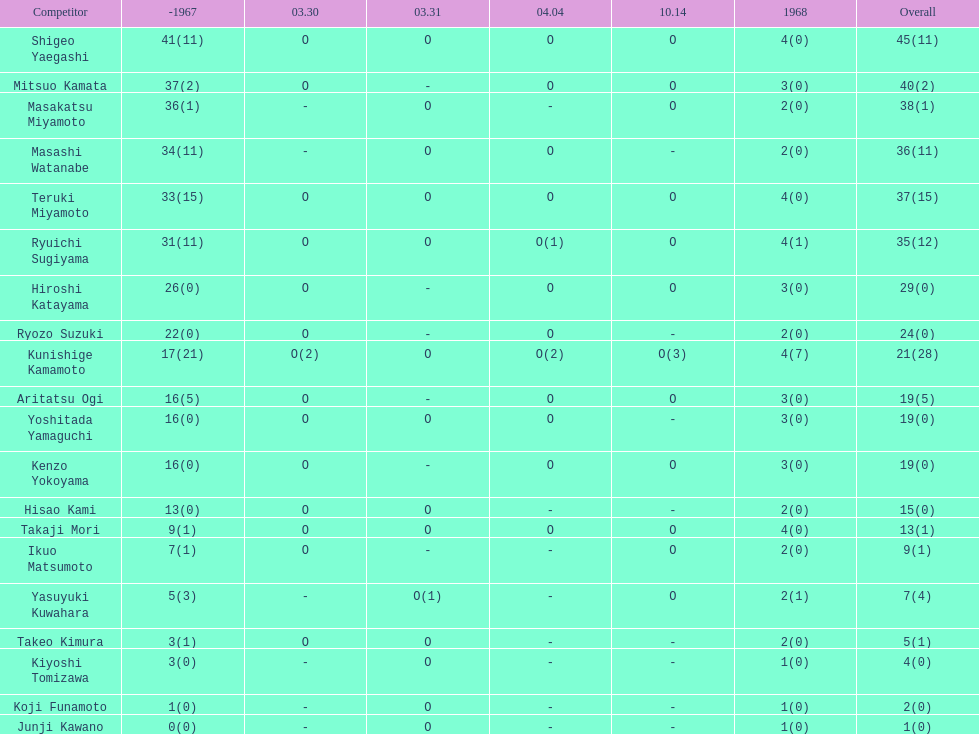How many players made an appearance that year? 20. 